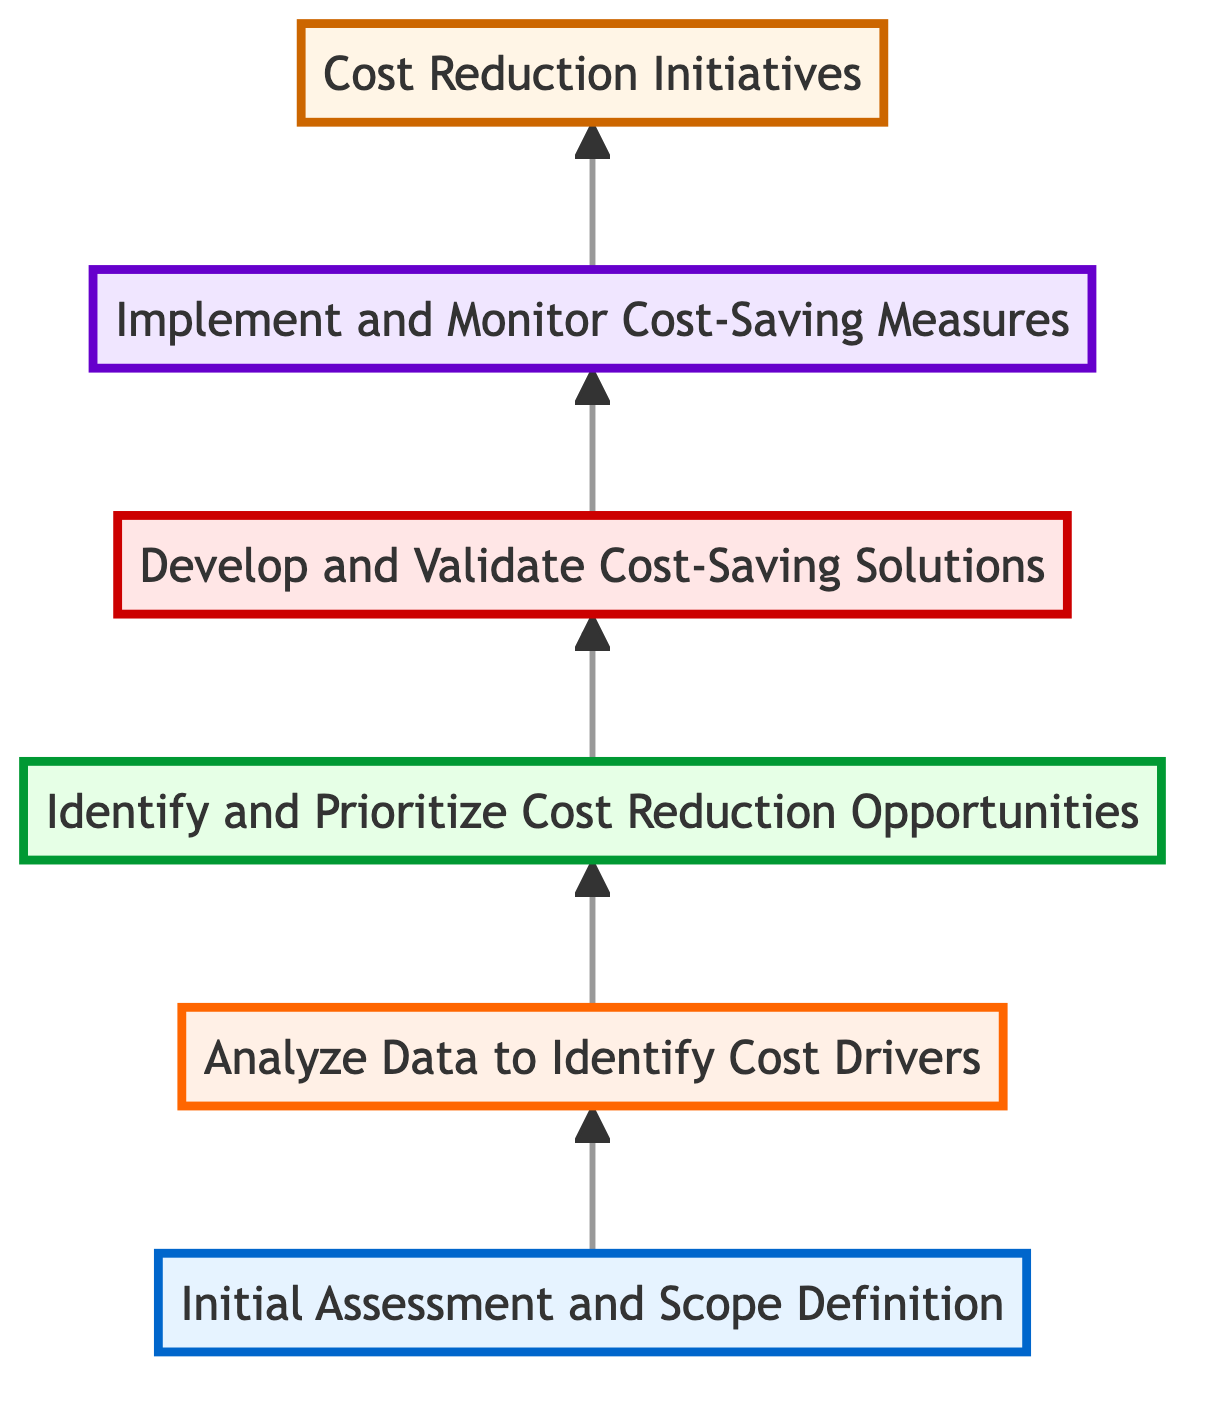What is the topmost level in the diagram? The topmost level is "Cost Reduction Initiatives", which represents the ultimate goal of this flow chart as indicated by the upward arrow reaching the final node.
Answer: Cost Reduction Initiatives How many levels are there in the diagram? The diagram has six levels as counted from the lowest node "Initial Assessment and Scope Definition" to the topmost node "Cost Reduction Initiatives".
Answer: Six What is the first step in the cost reduction process? The first step is "Initial Assessment and Scope Definition", which is at the bottom level of the diagram and represents the beginning of the process.
Answer: Initial Assessment and Scope Definition Which node comes after "Analyze Data to Identify Cost Drivers"? The node that comes after "Analyze Data to Identify Cost Drivers" is "Identify and Prioritize Cost Reduction Opportunities", showing the progression in the cost reduction initiatives.
Answer: Identify and Prioritize Cost Reduction Opportunities How does "Develop and Validate Cost-Saving Solutions" relate to the process? "Develop and Validate Cost-Saving Solutions" is the fourth step in the process, directly following "Identify and Prioritize Cost Reduction Opportunities" and preceding "Implement and Monitor Cost-Saving Measures".
Answer: It is the fourth step What is the relationship between "Implement and Monitor Cost-Saving Measures" and "Cost Reduction Initiatives"? "Implement and Monitor Cost-Saving Measures" is the penultimate step before reaching the final goal of "Cost Reduction Initiatives", indicating that implementations lead directly to the desired initiative.
Answer: It is the penultimate step Which element is prioritized before developing cost-saving solutions? Before developing cost-saving solutions, the process prioritizes "Identify and Prioritize Cost Reduction Opportunities", showing that solutions are formed based on prioritized opportunities.
Answer: Identify and Prioritize Cost Reduction Opportunities What is the direction of flow in this diagram? The direction of flow in this diagram is from bottom to top, indicated by arrows pointing up through the various levels of initiative steps.
Answer: Bottom to top How many nodes are present in the entire diagram? There are a total of six nodes in the diagram representing distinct steps in the cost reduction initiatives process.
Answer: Six 